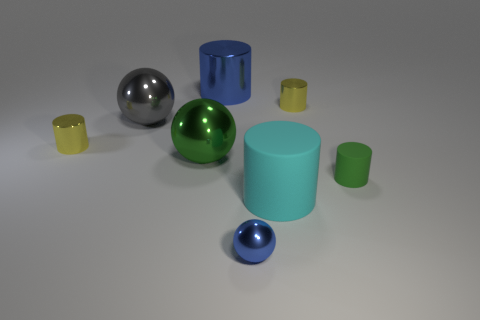Are there the same number of cyan things that are to the left of the cyan matte cylinder and cylinders in front of the large blue shiny cylinder?
Your answer should be very brief. No. There is a green sphere that is made of the same material as the big gray thing; what size is it?
Provide a succinct answer. Large. The big metallic cylinder is what color?
Give a very brief answer. Blue. What number of cylinders are the same color as the small metallic sphere?
Provide a short and direct response. 1. What material is the cyan cylinder that is the same size as the green metal object?
Keep it short and to the point. Rubber. There is a yellow shiny cylinder that is on the left side of the large cyan thing; are there any small blue metallic things that are behind it?
Your response must be concise. No. How many other things are there of the same color as the large rubber cylinder?
Offer a terse response. 0. What is the size of the cyan thing?
Keep it short and to the point. Large. Are any yellow cylinders visible?
Give a very brief answer. Yes. Is the number of balls that are to the right of the small green thing greater than the number of metal balls that are behind the large cyan rubber thing?
Your answer should be compact. No. 